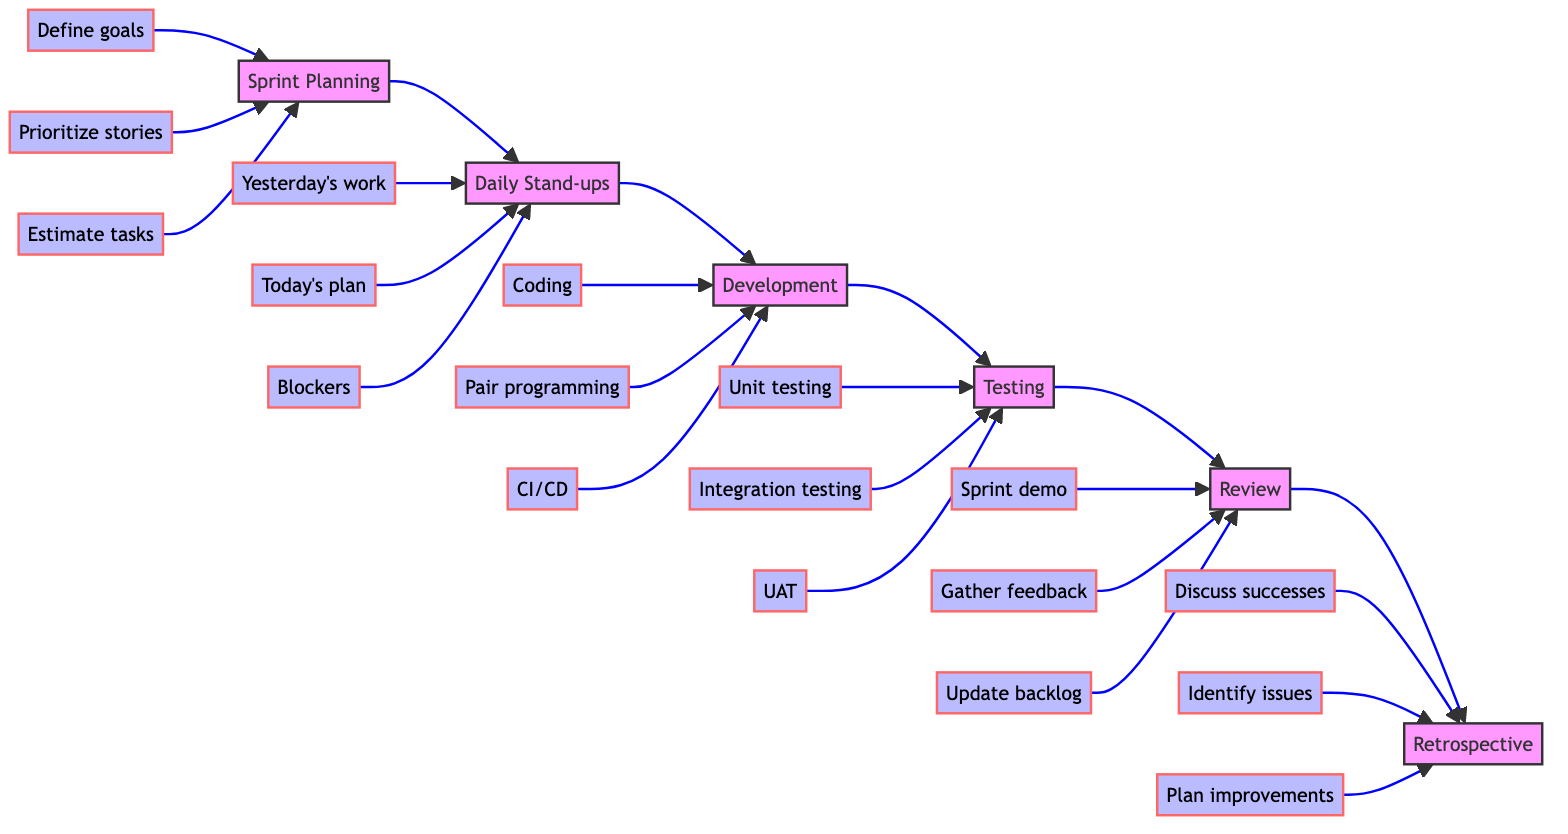What is the first step in the Agile Sprint Cycle? The flowchart indicates that "Sprint Planning" is the first step as it is the leftmost node in the sequence of steps.
Answer: Sprint Planning How many main steps are there in the Agile Sprint Cycle? The flowchart includes six main steps: Sprint Planning, Daily Stand-ups, Development, Testing, Review, and Retrospective, counting them provides the total.
Answer: Six What does the Daily Stand-up involve? The diagram outlines that the Daily Stand-up includes three tasks: asking about yesterday's work, today's plan, and identifying blockers.
Answer: Yesterday's work, Today's plan, Blockers What step comes right before Testing? By examining the directional arrows in the flowchart, it is clear that "Development" is the step directly preceding "Testing".
Answer: Development Which step follows Review? The diagram shows that "Retrospective" is the step that comes right after "Review", as indicated by the flow of arrows.
Answer: Retrospective How many tasks are outlined under the Development step? The flowchart lists three specific tasks under "Development": Coding, Pair programming, and Continuous integration/Continuous delivery (CI/CD), so counting these gives the total.
Answer: Three What are the three tasks in Testing? The flowchart specifies that the testing step involves three tasks: Unit testing, Integration testing, and User acceptance testing (UAT).
Answer: Unit testing, Integration testing, User acceptance testing What is the main purpose of the Retrospective step? According to the flowchart, the Retrospective is focused on reflecting on the past sprint to identify improvements.
Answer: Identify improvements Which task is associated with Sprint Planning that involves prioritization? The flowchart shows that "Prioritize stories" is one of the tasks associated with Sprint Planning, indicating the process of prioritization.
Answer: Prioritize stories What is the last task in the Review step? The flowchart indicates that "Update backlog" is the last task listed under the Review step, placing it at the end of that section.
Answer: Update backlog 